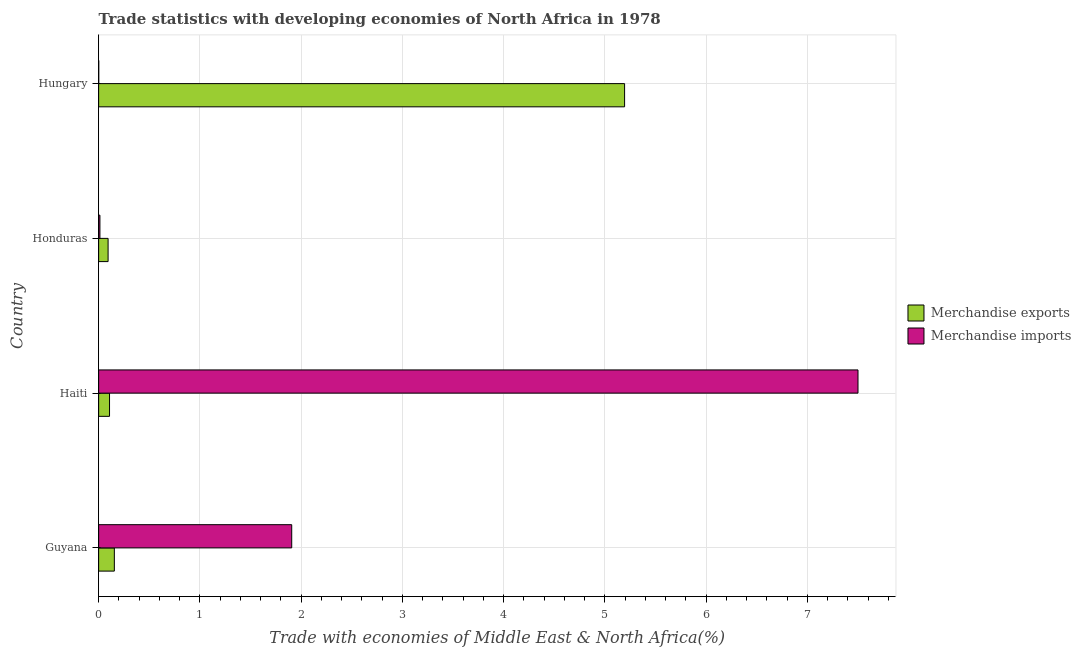How many different coloured bars are there?
Make the answer very short. 2. How many bars are there on the 2nd tick from the top?
Provide a short and direct response. 2. What is the label of the 3rd group of bars from the top?
Make the answer very short. Haiti. In how many cases, is the number of bars for a given country not equal to the number of legend labels?
Your answer should be very brief. 0. What is the merchandise imports in Guyana?
Offer a terse response. 1.91. Across all countries, what is the maximum merchandise imports?
Offer a terse response. 7.5. Across all countries, what is the minimum merchandise imports?
Provide a short and direct response. 0. In which country was the merchandise exports maximum?
Provide a short and direct response. Hungary. In which country was the merchandise imports minimum?
Your answer should be compact. Hungary. What is the total merchandise imports in the graph?
Your answer should be compact. 9.42. What is the difference between the merchandise imports in Honduras and that in Hungary?
Provide a succinct answer. 0.01. What is the difference between the merchandise exports in Hungary and the merchandise imports in Honduras?
Your answer should be compact. 5.18. What is the average merchandise imports per country?
Provide a short and direct response. 2.35. What is the difference between the merchandise imports and merchandise exports in Haiti?
Your answer should be very brief. 7.39. What is the ratio of the merchandise exports in Guyana to that in Honduras?
Ensure brevity in your answer.  1.66. What is the difference between the highest and the second highest merchandise exports?
Offer a terse response. 5.04. What does the 2nd bar from the top in Guyana represents?
Your answer should be very brief. Merchandise exports. What does the 1st bar from the bottom in Hungary represents?
Your answer should be compact. Merchandise exports. How many bars are there?
Keep it short and to the point. 8. How many countries are there in the graph?
Give a very brief answer. 4. What is the difference between two consecutive major ticks on the X-axis?
Your answer should be compact. 1. Are the values on the major ticks of X-axis written in scientific E-notation?
Provide a succinct answer. No. Does the graph contain any zero values?
Your answer should be very brief. No. What is the title of the graph?
Your answer should be compact. Trade statistics with developing economies of North Africa in 1978. What is the label or title of the X-axis?
Your answer should be very brief. Trade with economies of Middle East & North Africa(%). What is the Trade with economies of Middle East & North Africa(%) in Merchandise exports in Guyana?
Make the answer very short. 0.16. What is the Trade with economies of Middle East & North Africa(%) of Merchandise imports in Guyana?
Your answer should be compact. 1.91. What is the Trade with economies of Middle East & North Africa(%) of Merchandise exports in Haiti?
Your answer should be very brief. 0.11. What is the Trade with economies of Middle East & North Africa(%) of Merchandise imports in Haiti?
Your answer should be compact. 7.5. What is the Trade with economies of Middle East & North Africa(%) in Merchandise exports in Honduras?
Give a very brief answer. 0.09. What is the Trade with economies of Middle East & North Africa(%) in Merchandise imports in Honduras?
Keep it short and to the point. 0.01. What is the Trade with economies of Middle East & North Africa(%) of Merchandise exports in Hungary?
Make the answer very short. 5.2. What is the Trade with economies of Middle East & North Africa(%) of Merchandise imports in Hungary?
Offer a very short reply. 0. Across all countries, what is the maximum Trade with economies of Middle East & North Africa(%) in Merchandise exports?
Keep it short and to the point. 5.2. Across all countries, what is the maximum Trade with economies of Middle East & North Africa(%) in Merchandise imports?
Give a very brief answer. 7.5. Across all countries, what is the minimum Trade with economies of Middle East & North Africa(%) in Merchandise exports?
Provide a short and direct response. 0.09. Across all countries, what is the minimum Trade with economies of Middle East & North Africa(%) in Merchandise imports?
Your answer should be very brief. 0. What is the total Trade with economies of Middle East & North Africa(%) in Merchandise exports in the graph?
Give a very brief answer. 5.55. What is the total Trade with economies of Middle East & North Africa(%) in Merchandise imports in the graph?
Your answer should be compact. 9.42. What is the difference between the Trade with economies of Middle East & North Africa(%) of Merchandise exports in Guyana and that in Haiti?
Offer a very short reply. 0.05. What is the difference between the Trade with economies of Middle East & North Africa(%) of Merchandise imports in Guyana and that in Haiti?
Offer a terse response. -5.59. What is the difference between the Trade with economies of Middle East & North Africa(%) in Merchandise exports in Guyana and that in Honduras?
Give a very brief answer. 0.06. What is the difference between the Trade with economies of Middle East & North Africa(%) in Merchandise imports in Guyana and that in Honduras?
Your response must be concise. 1.89. What is the difference between the Trade with economies of Middle East & North Africa(%) in Merchandise exports in Guyana and that in Hungary?
Keep it short and to the point. -5.04. What is the difference between the Trade with economies of Middle East & North Africa(%) of Merchandise imports in Guyana and that in Hungary?
Offer a terse response. 1.91. What is the difference between the Trade with economies of Middle East & North Africa(%) in Merchandise exports in Haiti and that in Honduras?
Your answer should be very brief. 0.01. What is the difference between the Trade with economies of Middle East & North Africa(%) in Merchandise imports in Haiti and that in Honduras?
Offer a terse response. 7.49. What is the difference between the Trade with economies of Middle East & North Africa(%) in Merchandise exports in Haiti and that in Hungary?
Offer a very short reply. -5.09. What is the difference between the Trade with economies of Middle East & North Africa(%) of Merchandise imports in Haiti and that in Hungary?
Offer a very short reply. 7.5. What is the difference between the Trade with economies of Middle East & North Africa(%) of Merchandise exports in Honduras and that in Hungary?
Provide a succinct answer. -5.1. What is the difference between the Trade with economies of Middle East & North Africa(%) in Merchandise imports in Honduras and that in Hungary?
Ensure brevity in your answer.  0.01. What is the difference between the Trade with economies of Middle East & North Africa(%) in Merchandise exports in Guyana and the Trade with economies of Middle East & North Africa(%) in Merchandise imports in Haiti?
Keep it short and to the point. -7.35. What is the difference between the Trade with economies of Middle East & North Africa(%) of Merchandise exports in Guyana and the Trade with economies of Middle East & North Africa(%) of Merchandise imports in Honduras?
Your response must be concise. 0.14. What is the difference between the Trade with economies of Middle East & North Africa(%) of Merchandise exports in Guyana and the Trade with economies of Middle East & North Africa(%) of Merchandise imports in Hungary?
Give a very brief answer. 0.15. What is the difference between the Trade with economies of Middle East & North Africa(%) of Merchandise exports in Haiti and the Trade with economies of Middle East & North Africa(%) of Merchandise imports in Honduras?
Make the answer very short. 0.09. What is the difference between the Trade with economies of Middle East & North Africa(%) of Merchandise exports in Haiti and the Trade with economies of Middle East & North Africa(%) of Merchandise imports in Hungary?
Offer a terse response. 0.11. What is the difference between the Trade with economies of Middle East & North Africa(%) in Merchandise exports in Honduras and the Trade with economies of Middle East & North Africa(%) in Merchandise imports in Hungary?
Offer a very short reply. 0.09. What is the average Trade with economies of Middle East & North Africa(%) in Merchandise exports per country?
Make the answer very short. 1.39. What is the average Trade with economies of Middle East & North Africa(%) in Merchandise imports per country?
Offer a terse response. 2.36. What is the difference between the Trade with economies of Middle East & North Africa(%) of Merchandise exports and Trade with economies of Middle East & North Africa(%) of Merchandise imports in Guyana?
Offer a very short reply. -1.75. What is the difference between the Trade with economies of Middle East & North Africa(%) in Merchandise exports and Trade with economies of Middle East & North Africa(%) in Merchandise imports in Haiti?
Make the answer very short. -7.39. What is the difference between the Trade with economies of Middle East & North Africa(%) in Merchandise exports and Trade with economies of Middle East & North Africa(%) in Merchandise imports in Honduras?
Offer a very short reply. 0.08. What is the difference between the Trade with economies of Middle East & North Africa(%) in Merchandise exports and Trade with economies of Middle East & North Africa(%) in Merchandise imports in Hungary?
Offer a terse response. 5.19. What is the ratio of the Trade with economies of Middle East & North Africa(%) of Merchandise exports in Guyana to that in Haiti?
Your response must be concise. 1.44. What is the ratio of the Trade with economies of Middle East & North Africa(%) in Merchandise imports in Guyana to that in Haiti?
Make the answer very short. 0.25. What is the ratio of the Trade with economies of Middle East & North Africa(%) of Merchandise exports in Guyana to that in Honduras?
Your answer should be compact. 1.66. What is the ratio of the Trade with economies of Middle East & North Africa(%) in Merchandise imports in Guyana to that in Honduras?
Provide a succinct answer. 149.49. What is the ratio of the Trade with economies of Middle East & North Africa(%) in Merchandise exports in Guyana to that in Hungary?
Provide a succinct answer. 0.03. What is the ratio of the Trade with economies of Middle East & North Africa(%) of Merchandise imports in Guyana to that in Hungary?
Your answer should be very brief. 1884.49. What is the ratio of the Trade with economies of Middle East & North Africa(%) in Merchandise exports in Haiti to that in Honduras?
Make the answer very short. 1.15. What is the ratio of the Trade with economies of Middle East & North Africa(%) of Merchandise imports in Haiti to that in Honduras?
Keep it short and to the point. 587.92. What is the ratio of the Trade with economies of Middle East & North Africa(%) in Merchandise exports in Haiti to that in Hungary?
Offer a very short reply. 0.02. What is the ratio of the Trade with economies of Middle East & North Africa(%) of Merchandise imports in Haiti to that in Hungary?
Keep it short and to the point. 7411.48. What is the ratio of the Trade with economies of Middle East & North Africa(%) of Merchandise exports in Honduras to that in Hungary?
Provide a short and direct response. 0.02. What is the ratio of the Trade with economies of Middle East & North Africa(%) in Merchandise imports in Honduras to that in Hungary?
Provide a succinct answer. 12.61. What is the difference between the highest and the second highest Trade with economies of Middle East & North Africa(%) of Merchandise exports?
Keep it short and to the point. 5.04. What is the difference between the highest and the second highest Trade with economies of Middle East & North Africa(%) in Merchandise imports?
Offer a very short reply. 5.59. What is the difference between the highest and the lowest Trade with economies of Middle East & North Africa(%) in Merchandise exports?
Your answer should be very brief. 5.1. What is the difference between the highest and the lowest Trade with economies of Middle East & North Africa(%) of Merchandise imports?
Provide a succinct answer. 7.5. 